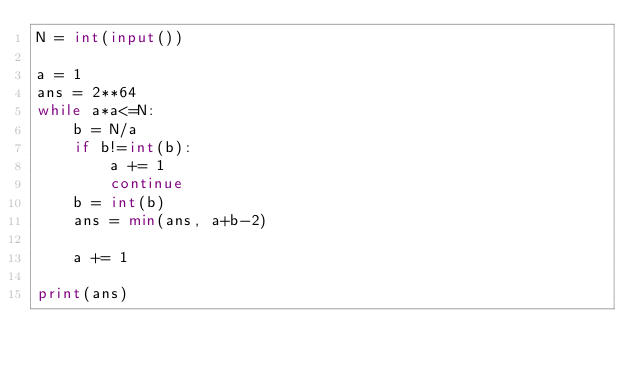Convert code to text. <code><loc_0><loc_0><loc_500><loc_500><_Python_>N = int(input())

a = 1
ans = 2**64
while a*a<=N:
    b = N/a
    if b!=int(b):
        a += 1
        continue
    b = int(b)
    ans = min(ans, a+b-2)

    a += 1

print(ans)
    

</code> 